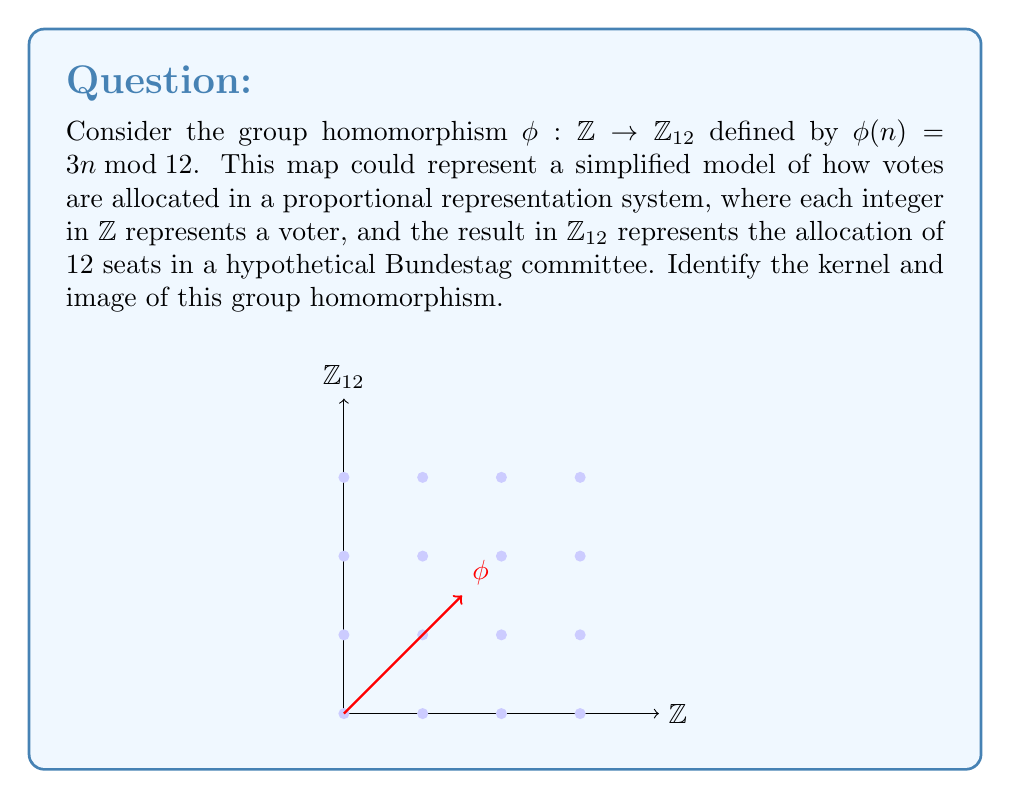Can you answer this question? 1) To find the kernel, we need to determine all elements $n \in \mathbb{Z}$ such that $\phi(n) = 0 \bmod 12$.

2) This means we need to solve the equation:
   $3n \equiv 0 \pmod{12}$

3) Dividing both sides by 3:
   $n \equiv 0 \pmod{4}$

4) Therefore, the kernel consists of all multiples of 4 in $\mathbb{Z}$:
   $\text{ker}(\phi) = \{4k : k \in \mathbb{Z}\} = 4\mathbb{Z}$

5) To find the image, we need to determine all possible values of $3n \bmod 12$ for $n \in \mathbb{Z}$.

6) The possible values are:
   For $n = 0$: $3 \cdot 0 \equiv 0 \pmod{12}$
   For $n = 1$: $3 \cdot 1 \equiv 3 \pmod{12}$
   For $n = 2$: $3 \cdot 2 \equiv 6 \pmod{12}$
   For $n = 3$: $3 \cdot 3 \equiv 9 \pmod{12}$
   For $n = 4$: $3 \cdot 4 \equiv 0 \pmod{12}$

7) We see that the pattern repeats after this, so the image consists of the elements $\{0, 3, 6, 9\}$ in $\mathbb{Z}_{12}$.
Answer: $\text{ker}(\phi) = 4\mathbb{Z}$, $\text{im}(\phi) = \{0, 3, 6, 9\}$ 